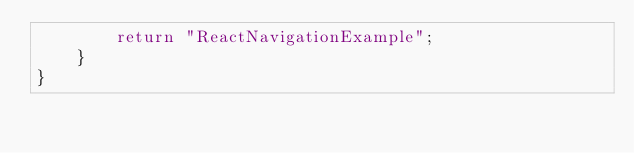Convert code to text. <code><loc_0><loc_0><loc_500><loc_500><_Java_>        return "ReactNavigationExample";
    }
}
</code> 